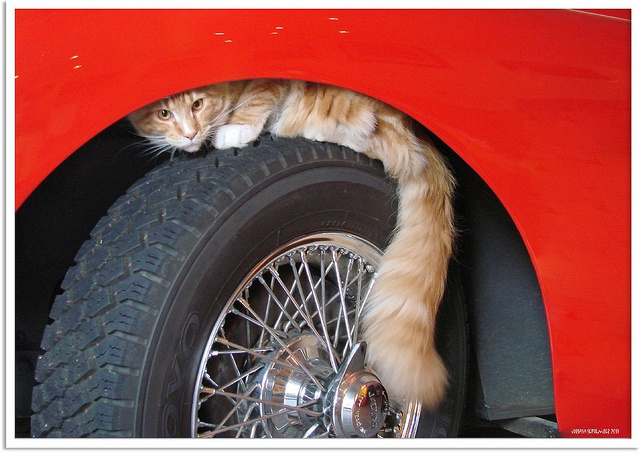Describe the objects in this image and their specific colors. I can see car in red, black, gray, white, and blue tones and cat in white, tan, darkgray, and gray tones in this image. 